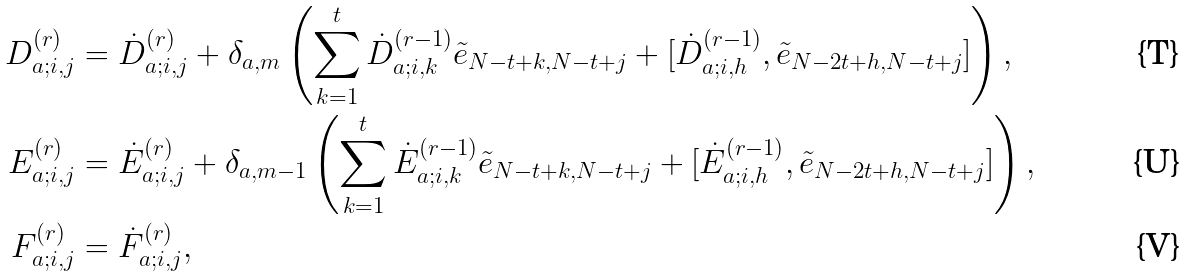Convert formula to latex. <formula><loc_0><loc_0><loc_500><loc_500>D _ { a ; i , j } ^ { ( r ) } & = \dot { D } _ { a ; i , j } ^ { ( r ) } + \delta _ { a , m } \left ( \sum _ { k = 1 } ^ { t } \dot { D } _ { a ; i , k } ^ { ( r - 1 ) } \tilde { e } _ { N - t + k , N - t + j } + [ \dot { D } _ { a ; i , h } ^ { ( r - 1 ) } , \tilde { e } _ { N - 2 t + h , N - t + j } ] \right ) , \\ E _ { a ; i , j } ^ { ( r ) } & = \dot { E } _ { a ; i , j } ^ { ( r ) } + \delta _ { a , m - 1 } \left ( \sum _ { k = 1 } ^ { t } \dot { E } _ { a ; i , k } ^ { ( r - 1 ) } \tilde { e } _ { N - t + k , N - t + j } + [ \dot { E } _ { a ; i , h } ^ { ( r - 1 ) } , \tilde { e } _ { N - 2 t + h , N - t + j } ] \right ) , \\ F _ { a ; i , j } ^ { ( r ) } & = \dot { F } _ { a ; i , j } ^ { ( r ) } ,</formula> 